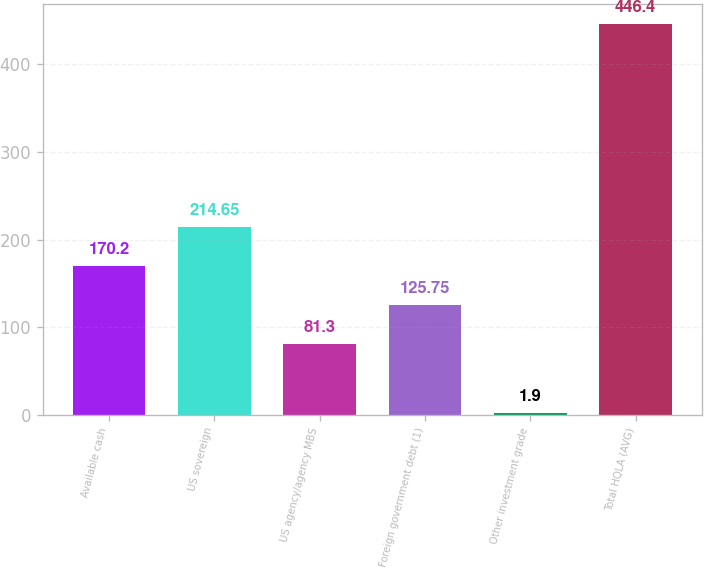Convert chart. <chart><loc_0><loc_0><loc_500><loc_500><bar_chart><fcel>Available cash<fcel>US sovereign<fcel>US agency/agency MBS<fcel>Foreign government debt (1)<fcel>Other investment grade<fcel>Total HQLA (AVG)<nl><fcel>170.2<fcel>214.65<fcel>81.3<fcel>125.75<fcel>1.9<fcel>446.4<nl></chart> 